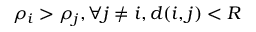Convert formula to latex. <formula><loc_0><loc_0><loc_500><loc_500>\rho _ { i } > \rho _ { j } , \forall j \neq i , d ( i , j ) < R</formula> 